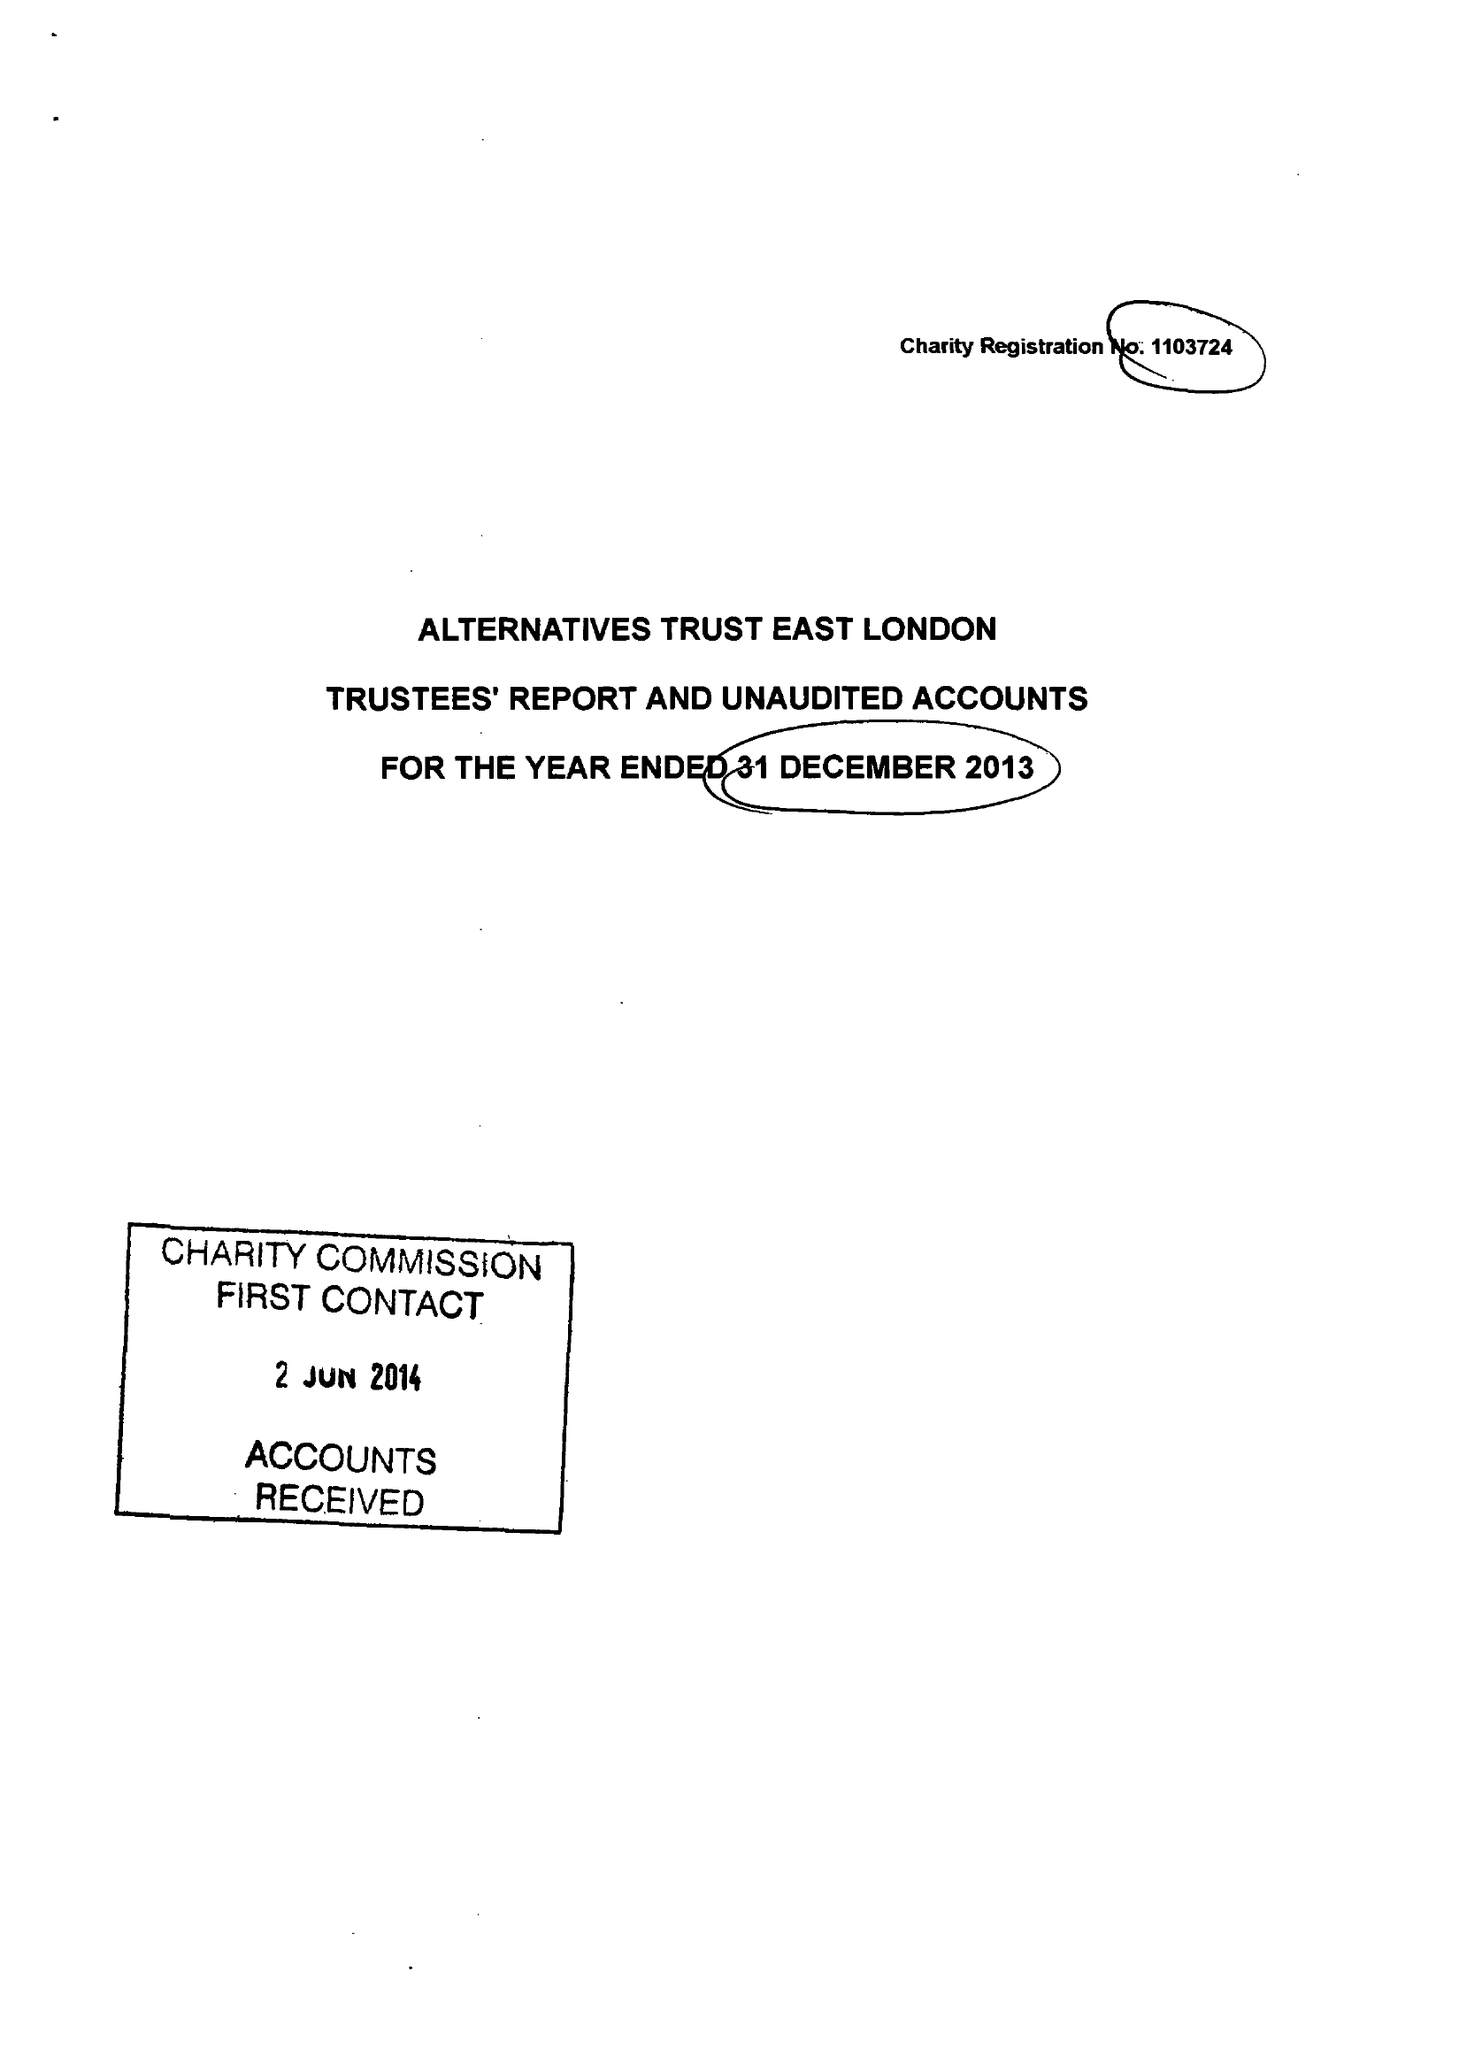What is the value for the report_date?
Answer the question using a single word or phrase. 2013-12-31 